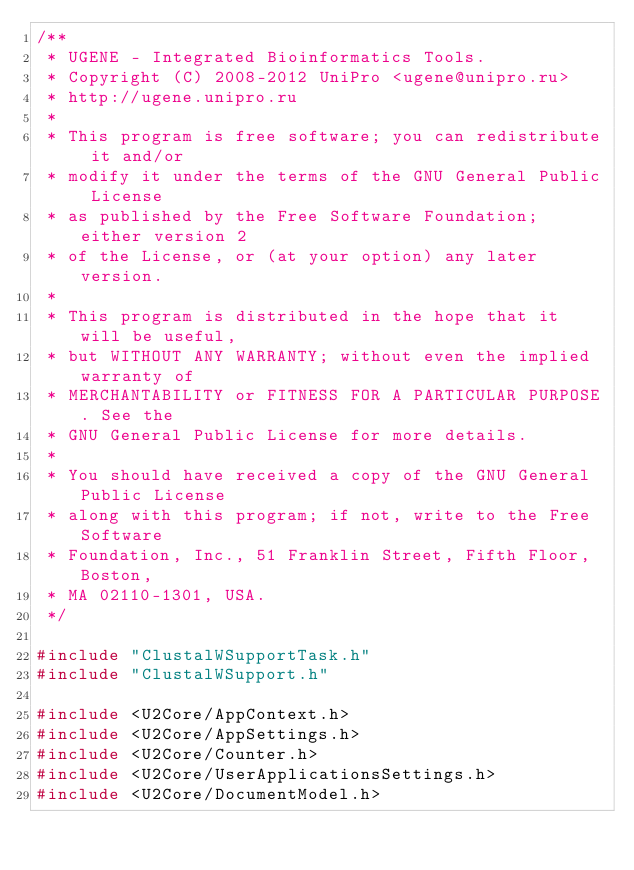Convert code to text. <code><loc_0><loc_0><loc_500><loc_500><_C++_>/**
 * UGENE - Integrated Bioinformatics Tools.
 * Copyright (C) 2008-2012 UniPro <ugene@unipro.ru>
 * http://ugene.unipro.ru
 *
 * This program is free software; you can redistribute it and/or
 * modify it under the terms of the GNU General Public License
 * as published by the Free Software Foundation; either version 2
 * of the License, or (at your option) any later version.
 *
 * This program is distributed in the hope that it will be useful,
 * but WITHOUT ANY WARRANTY; without even the implied warranty of
 * MERCHANTABILITY or FITNESS FOR A PARTICULAR PURPOSE. See the
 * GNU General Public License for more details.
 *
 * You should have received a copy of the GNU General Public License
 * along with this program; if not, write to the Free Software
 * Foundation, Inc., 51 Franklin Street, Fifth Floor, Boston,
 * MA 02110-1301, USA.
 */

#include "ClustalWSupportTask.h"
#include "ClustalWSupport.h"

#include <U2Core/AppContext.h>
#include <U2Core/AppSettings.h>
#include <U2Core/Counter.h>
#include <U2Core/UserApplicationsSettings.h>
#include <U2Core/DocumentModel.h></code> 